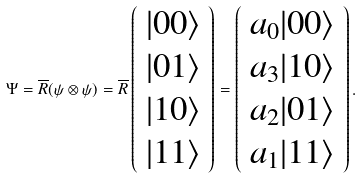<formula> <loc_0><loc_0><loc_500><loc_500>\Psi = \overline { R } ( \psi \otimes \psi ) = \overline { R } \left ( \begin{array} { c } | 0 0 \rangle \\ | 0 1 \rangle \\ | 1 0 \rangle \\ | 1 1 \rangle \end{array} \right ) = \left ( \begin{array} { c } a _ { 0 } | 0 0 \rangle \\ a _ { 3 } | 1 0 \rangle \\ a _ { 2 } | 0 1 \rangle \\ a _ { 1 } | 1 1 \rangle \end{array} \right ) .</formula> 